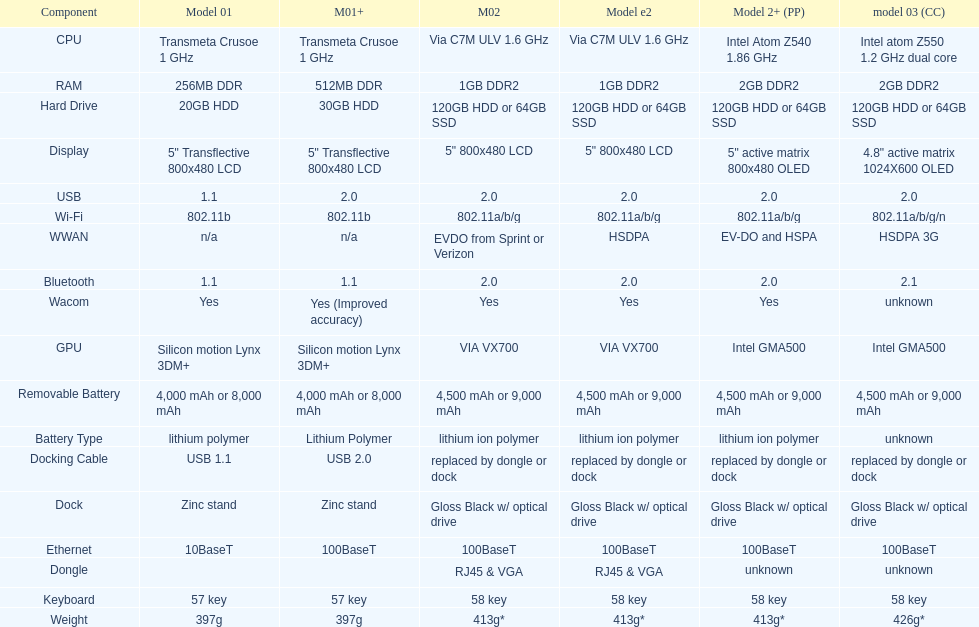How many models have 1.6ghz? 2. 